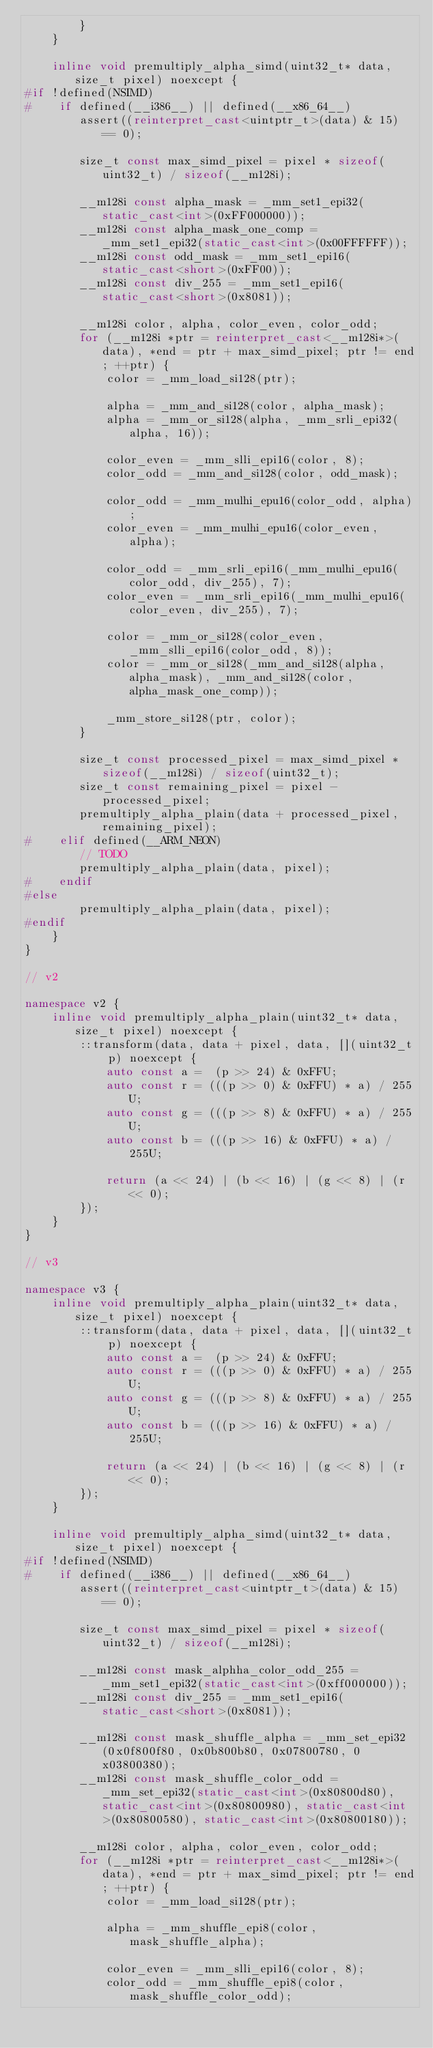<code> <loc_0><loc_0><loc_500><loc_500><_C++_>        }
    }

    inline void premultiply_alpha_simd(uint32_t* data, size_t pixel) noexcept {
#if !defined(NSIMD)
#    if defined(__i386__) || defined(__x86_64__)
        assert((reinterpret_cast<uintptr_t>(data) & 15) == 0);

        size_t const max_simd_pixel = pixel * sizeof(uint32_t) / sizeof(__m128i);

        __m128i const alpha_mask = _mm_set1_epi32(static_cast<int>(0xFF000000));
        __m128i const alpha_mask_one_comp = _mm_set1_epi32(static_cast<int>(0x00FFFFFF));
        __m128i const odd_mask = _mm_set1_epi16(static_cast<short>(0xFF00));
        __m128i const div_255 = _mm_set1_epi16(static_cast<short>(0x8081));

        __m128i color, alpha, color_even, color_odd;
        for (__m128i *ptr = reinterpret_cast<__m128i*>(data), *end = ptr + max_simd_pixel; ptr != end; ++ptr) {
            color = _mm_load_si128(ptr);

            alpha = _mm_and_si128(color, alpha_mask);
            alpha = _mm_or_si128(alpha, _mm_srli_epi32(alpha, 16));

            color_even = _mm_slli_epi16(color, 8);
            color_odd = _mm_and_si128(color, odd_mask);

            color_odd = _mm_mulhi_epu16(color_odd, alpha);
            color_even = _mm_mulhi_epu16(color_even, alpha);

            color_odd = _mm_srli_epi16(_mm_mulhi_epu16(color_odd, div_255), 7);
            color_even = _mm_srli_epi16(_mm_mulhi_epu16(color_even, div_255), 7);

            color = _mm_or_si128(color_even, _mm_slli_epi16(color_odd, 8));
            color = _mm_or_si128(_mm_and_si128(alpha, alpha_mask), _mm_and_si128(color, alpha_mask_one_comp));

            _mm_store_si128(ptr, color);
        }

        size_t const processed_pixel = max_simd_pixel * sizeof(__m128i) / sizeof(uint32_t);
        size_t const remaining_pixel = pixel - processed_pixel;
        premultiply_alpha_plain(data + processed_pixel, remaining_pixel);
#    elif defined(__ARM_NEON)
        // TODO
        premultiply_alpha_plain(data, pixel);
#    endif
#else
        premultiply_alpha_plain(data, pixel);
#endif
    }
}

// v2

namespace v2 {
    inline void premultiply_alpha_plain(uint32_t* data, size_t pixel) noexcept {
        ::transform(data, data + pixel, data, [](uint32_t p) noexcept {
            auto const a =  (p >> 24) & 0xFFU;
            auto const r = (((p >> 0) & 0xFFU) * a) / 255U;
            auto const g = (((p >> 8) & 0xFFU) * a) / 255U;
            auto const b = (((p >> 16) & 0xFFU) * a) / 255U;

            return (a << 24) | (b << 16) | (g << 8) | (r << 0);
        });
    }
}

// v3

namespace v3 {
    inline void premultiply_alpha_plain(uint32_t* data, size_t pixel) noexcept {
        ::transform(data, data + pixel, data, [](uint32_t p) noexcept {
            auto const a =  (p >> 24) & 0xFFU;
            auto const r = (((p >> 0) & 0xFFU) * a) / 255U;
            auto const g = (((p >> 8) & 0xFFU) * a) / 255U;
            auto const b = (((p >> 16) & 0xFFU) * a) / 255U;

            return (a << 24) | (b << 16) | (g << 8) | (r << 0);
        });
    }

    inline void premultiply_alpha_simd(uint32_t* data, size_t pixel) noexcept {
#if !defined(NSIMD)
#    if defined(__i386__) || defined(__x86_64__)
        assert((reinterpret_cast<uintptr_t>(data) & 15) == 0);

        size_t const max_simd_pixel = pixel * sizeof(uint32_t) / sizeof(__m128i);

        __m128i const mask_alphha_color_odd_255 = _mm_set1_epi32(static_cast<int>(0xff000000));
        __m128i const div_255 = _mm_set1_epi16(static_cast<short>(0x8081));

        __m128i const mask_shuffle_alpha = _mm_set_epi32(0x0f800f80, 0x0b800b80, 0x07800780, 0x03800380);
        __m128i const mask_shuffle_color_odd = _mm_set_epi32(static_cast<int>(0x80800d80), static_cast<int>(0x80800980), static_cast<int>(0x80800580), static_cast<int>(0x80800180));

        __m128i color, alpha, color_even, color_odd;
        for (__m128i *ptr = reinterpret_cast<__m128i*>(data), *end = ptr + max_simd_pixel; ptr != end; ++ptr) {
            color = _mm_load_si128(ptr);

            alpha = _mm_shuffle_epi8(color, mask_shuffle_alpha);

            color_even = _mm_slli_epi16(color, 8);
            color_odd = _mm_shuffle_epi8(color, mask_shuffle_color_odd);</code> 